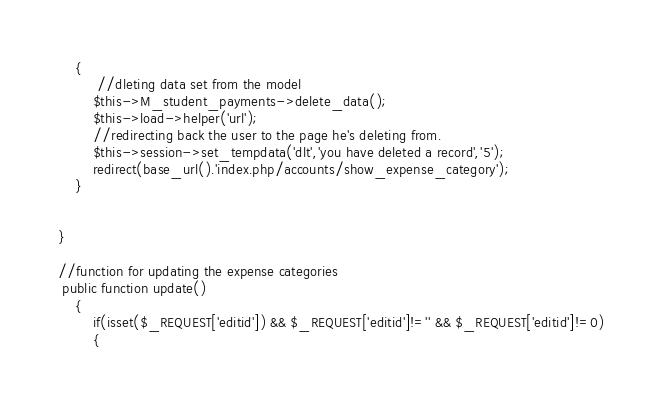Convert code to text. <code><loc_0><loc_0><loc_500><loc_500><_PHP_>    {
         //dleting data set from the model
        $this->M_student_payments->delete_data();
        $this->load->helper('url');
        //redirecting back the user to the page he's deleting from.
        $this->session->set_tempdata('dlt','you have deleted a record','5');
        redirect(base_url().'index.php/accounts/show_expense_category');
    }
    
    
}

//function for updating the expense categories
 public function update()
    {
        if(isset($_REQUEST['editid']) && $_REQUEST['editid']!='' && $_REQUEST['editid']!=0)
        {</code> 